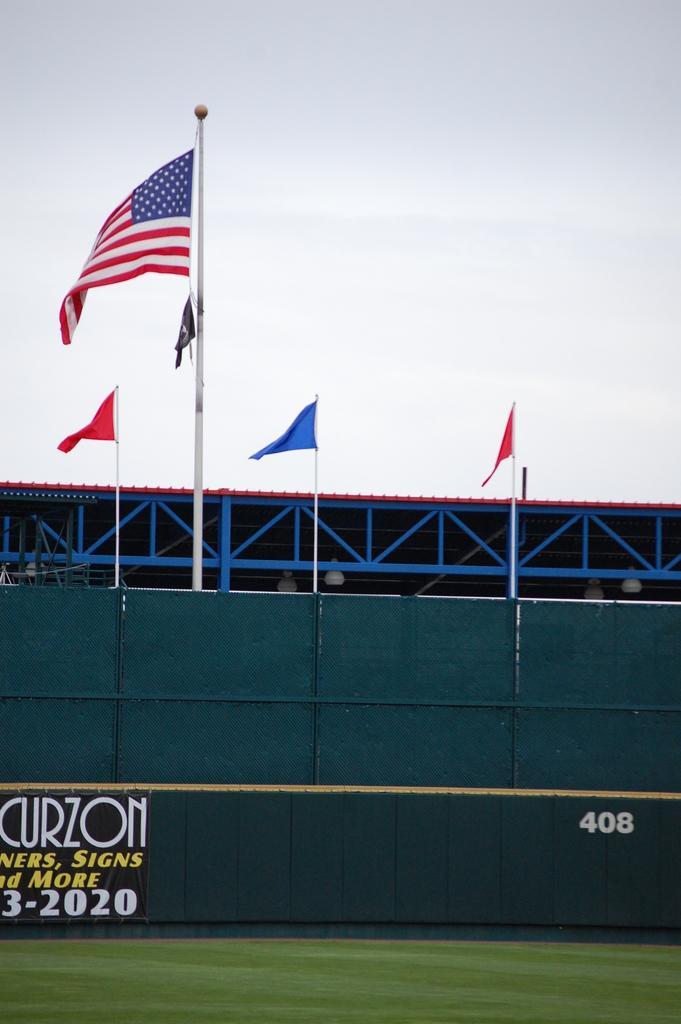Could you give a brief overview of what you see in this image? This picture consists of a ground at the bottom and I can see blue color fence and at the top of fence I can see flags and at the top I can see the sky. 